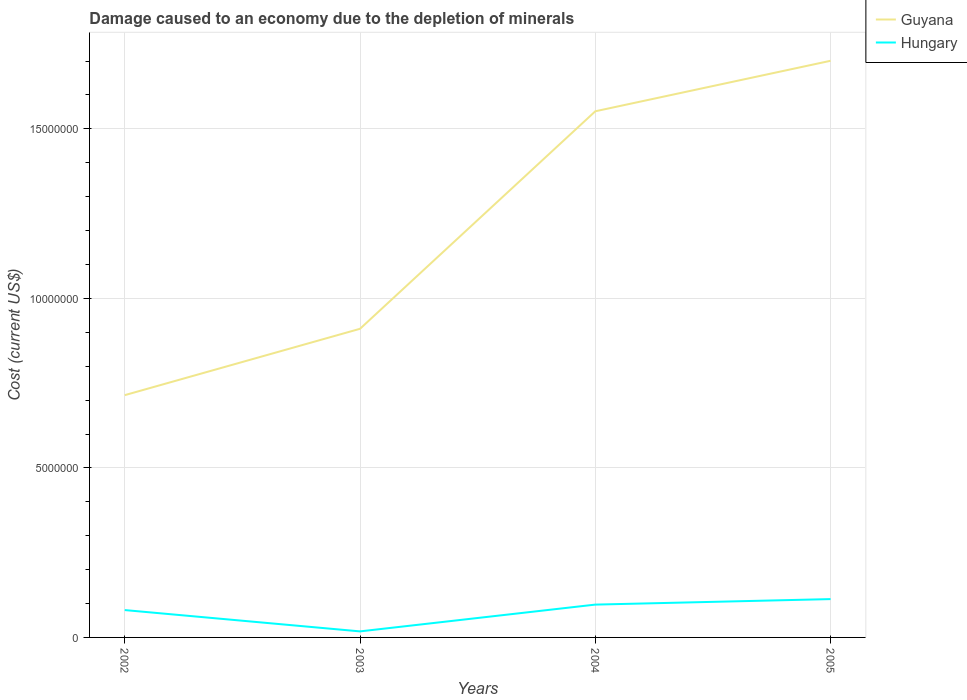How many different coloured lines are there?
Your answer should be compact. 2. Is the number of lines equal to the number of legend labels?
Offer a very short reply. Yes. Across all years, what is the maximum cost of damage caused due to the depletion of minerals in Guyana?
Your answer should be very brief. 7.15e+06. In which year was the cost of damage caused due to the depletion of minerals in Hungary maximum?
Offer a terse response. 2003. What is the total cost of damage caused due to the depletion of minerals in Guyana in the graph?
Keep it short and to the point. -7.91e+06. What is the difference between the highest and the second highest cost of damage caused due to the depletion of minerals in Guyana?
Offer a terse response. 9.86e+06. Are the values on the major ticks of Y-axis written in scientific E-notation?
Your response must be concise. No. Does the graph contain any zero values?
Offer a terse response. No. Does the graph contain grids?
Provide a succinct answer. Yes. How are the legend labels stacked?
Make the answer very short. Vertical. What is the title of the graph?
Your answer should be compact. Damage caused to an economy due to the depletion of minerals. Does "Singapore" appear as one of the legend labels in the graph?
Offer a terse response. No. What is the label or title of the Y-axis?
Offer a terse response. Cost (current US$). What is the Cost (current US$) in Guyana in 2002?
Offer a very short reply. 7.15e+06. What is the Cost (current US$) in Hungary in 2002?
Offer a very short reply. 8.07e+05. What is the Cost (current US$) of Guyana in 2003?
Provide a short and direct response. 9.10e+06. What is the Cost (current US$) in Hungary in 2003?
Your response must be concise. 1.78e+05. What is the Cost (current US$) in Guyana in 2004?
Your response must be concise. 1.55e+07. What is the Cost (current US$) of Hungary in 2004?
Keep it short and to the point. 9.68e+05. What is the Cost (current US$) of Guyana in 2005?
Keep it short and to the point. 1.70e+07. What is the Cost (current US$) in Hungary in 2005?
Offer a terse response. 1.13e+06. Across all years, what is the maximum Cost (current US$) of Guyana?
Provide a succinct answer. 1.70e+07. Across all years, what is the maximum Cost (current US$) in Hungary?
Ensure brevity in your answer.  1.13e+06. Across all years, what is the minimum Cost (current US$) in Guyana?
Offer a terse response. 7.15e+06. Across all years, what is the minimum Cost (current US$) of Hungary?
Offer a terse response. 1.78e+05. What is the total Cost (current US$) of Guyana in the graph?
Your answer should be compact. 4.88e+07. What is the total Cost (current US$) in Hungary in the graph?
Give a very brief answer. 3.08e+06. What is the difference between the Cost (current US$) of Guyana in 2002 and that in 2003?
Make the answer very short. -1.96e+06. What is the difference between the Cost (current US$) of Hungary in 2002 and that in 2003?
Make the answer very short. 6.29e+05. What is the difference between the Cost (current US$) of Guyana in 2002 and that in 2004?
Keep it short and to the point. -8.37e+06. What is the difference between the Cost (current US$) in Hungary in 2002 and that in 2004?
Provide a short and direct response. -1.61e+05. What is the difference between the Cost (current US$) in Guyana in 2002 and that in 2005?
Your answer should be compact. -9.86e+06. What is the difference between the Cost (current US$) in Hungary in 2002 and that in 2005?
Provide a short and direct response. -3.24e+05. What is the difference between the Cost (current US$) of Guyana in 2003 and that in 2004?
Your answer should be compact. -6.42e+06. What is the difference between the Cost (current US$) in Hungary in 2003 and that in 2004?
Provide a succinct answer. -7.90e+05. What is the difference between the Cost (current US$) in Guyana in 2003 and that in 2005?
Provide a succinct answer. -7.91e+06. What is the difference between the Cost (current US$) in Hungary in 2003 and that in 2005?
Your answer should be very brief. -9.53e+05. What is the difference between the Cost (current US$) of Guyana in 2004 and that in 2005?
Offer a very short reply. -1.49e+06. What is the difference between the Cost (current US$) of Hungary in 2004 and that in 2005?
Make the answer very short. -1.63e+05. What is the difference between the Cost (current US$) of Guyana in 2002 and the Cost (current US$) of Hungary in 2003?
Ensure brevity in your answer.  6.97e+06. What is the difference between the Cost (current US$) of Guyana in 2002 and the Cost (current US$) of Hungary in 2004?
Keep it short and to the point. 6.18e+06. What is the difference between the Cost (current US$) in Guyana in 2002 and the Cost (current US$) in Hungary in 2005?
Your response must be concise. 6.02e+06. What is the difference between the Cost (current US$) in Guyana in 2003 and the Cost (current US$) in Hungary in 2004?
Make the answer very short. 8.14e+06. What is the difference between the Cost (current US$) of Guyana in 2003 and the Cost (current US$) of Hungary in 2005?
Your response must be concise. 7.97e+06. What is the difference between the Cost (current US$) in Guyana in 2004 and the Cost (current US$) in Hungary in 2005?
Provide a succinct answer. 1.44e+07. What is the average Cost (current US$) of Guyana per year?
Keep it short and to the point. 1.22e+07. What is the average Cost (current US$) in Hungary per year?
Keep it short and to the point. 7.71e+05. In the year 2002, what is the difference between the Cost (current US$) in Guyana and Cost (current US$) in Hungary?
Your answer should be compact. 6.34e+06. In the year 2003, what is the difference between the Cost (current US$) of Guyana and Cost (current US$) of Hungary?
Your answer should be very brief. 8.93e+06. In the year 2004, what is the difference between the Cost (current US$) of Guyana and Cost (current US$) of Hungary?
Keep it short and to the point. 1.46e+07. In the year 2005, what is the difference between the Cost (current US$) of Guyana and Cost (current US$) of Hungary?
Provide a short and direct response. 1.59e+07. What is the ratio of the Cost (current US$) in Guyana in 2002 to that in 2003?
Your answer should be compact. 0.79. What is the ratio of the Cost (current US$) of Hungary in 2002 to that in 2003?
Provide a short and direct response. 4.53. What is the ratio of the Cost (current US$) in Guyana in 2002 to that in 2004?
Provide a short and direct response. 0.46. What is the ratio of the Cost (current US$) in Hungary in 2002 to that in 2004?
Provide a short and direct response. 0.83. What is the ratio of the Cost (current US$) of Guyana in 2002 to that in 2005?
Ensure brevity in your answer.  0.42. What is the ratio of the Cost (current US$) of Hungary in 2002 to that in 2005?
Your answer should be very brief. 0.71. What is the ratio of the Cost (current US$) in Guyana in 2003 to that in 2004?
Your answer should be very brief. 0.59. What is the ratio of the Cost (current US$) of Hungary in 2003 to that in 2004?
Give a very brief answer. 0.18. What is the ratio of the Cost (current US$) in Guyana in 2003 to that in 2005?
Offer a very short reply. 0.54. What is the ratio of the Cost (current US$) of Hungary in 2003 to that in 2005?
Provide a short and direct response. 0.16. What is the ratio of the Cost (current US$) in Guyana in 2004 to that in 2005?
Keep it short and to the point. 0.91. What is the ratio of the Cost (current US$) of Hungary in 2004 to that in 2005?
Offer a terse response. 0.86. What is the difference between the highest and the second highest Cost (current US$) of Guyana?
Provide a succinct answer. 1.49e+06. What is the difference between the highest and the second highest Cost (current US$) in Hungary?
Your response must be concise. 1.63e+05. What is the difference between the highest and the lowest Cost (current US$) in Guyana?
Your answer should be very brief. 9.86e+06. What is the difference between the highest and the lowest Cost (current US$) in Hungary?
Your response must be concise. 9.53e+05. 